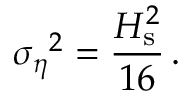Convert formula to latex. <formula><loc_0><loc_0><loc_500><loc_500>{ \sigma _ { \eta } } ^ { 2 } = \frac { H _ { s } ^ { 2 } } { 1 6 } \, .</formula> 